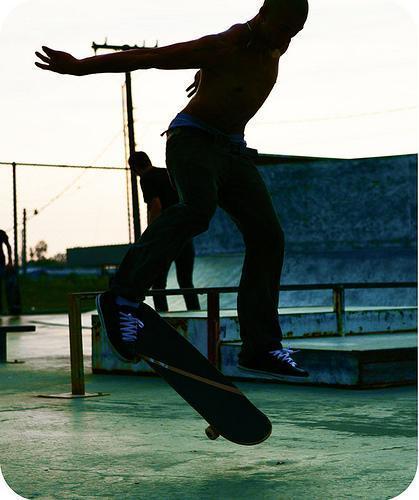How many legs does the person have?
Give a very brief answer. 2. How many people are there?
Give a very brief answer. 2. How many drinks cups have straw?
Give a very brief answer. 0. 